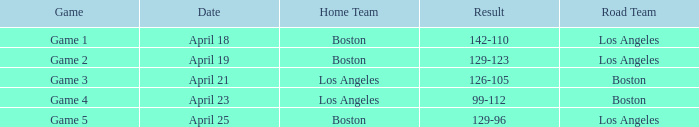WHAT IS THE RESULT OF THE GAME ON APRIL 23? 99-112. 